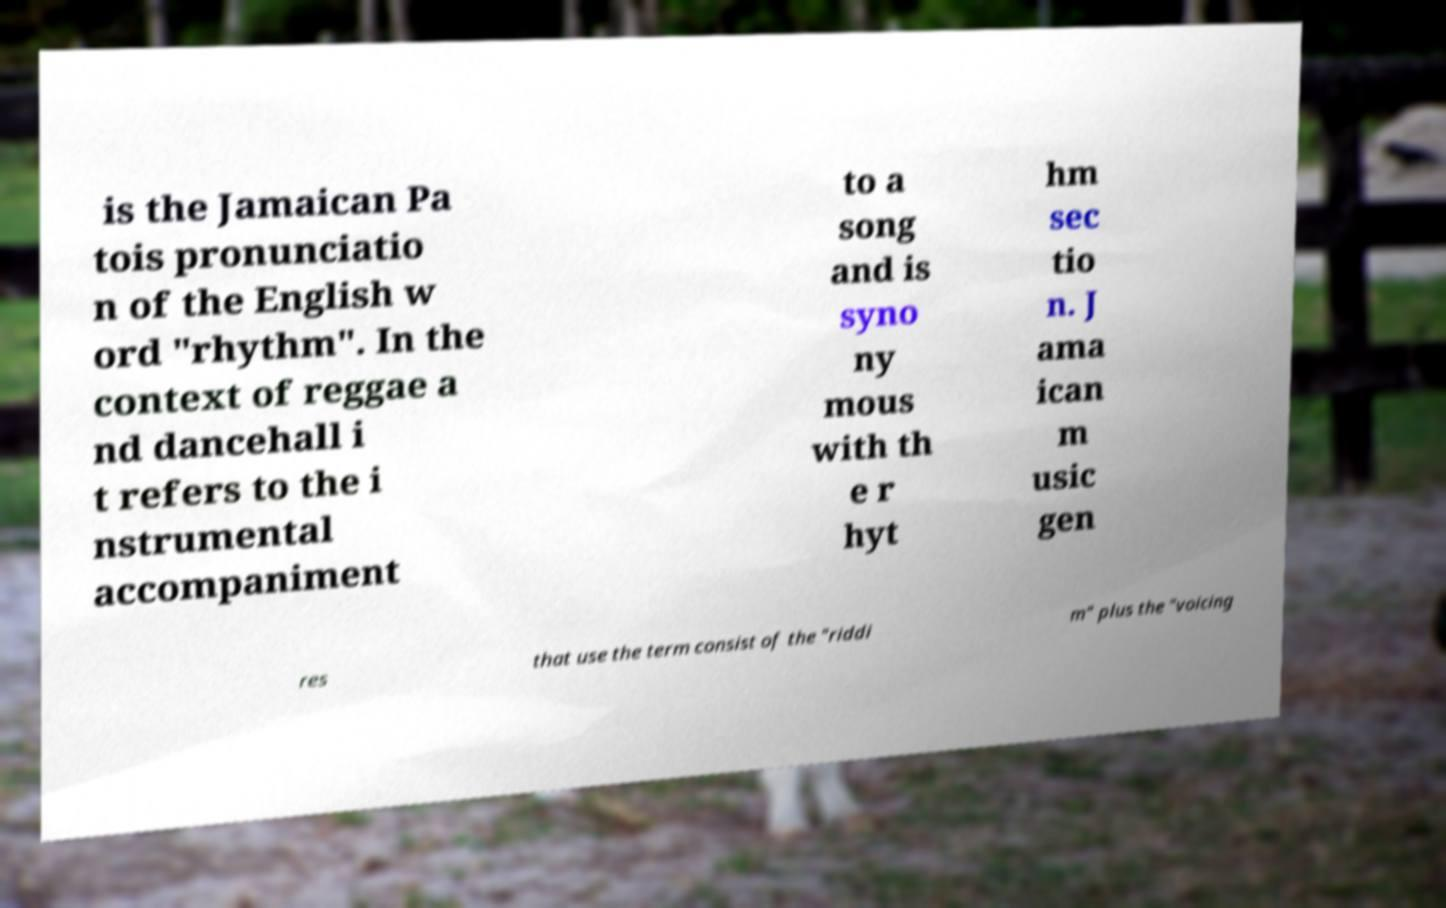Can you accurately transcribe the text from the provided image for me? is the Jamaican Pa tois pronunciatio n of the English w ord "rhythm". In the context of reggae a nd dancehall i t refers to the i nstrumental accompaniment to a song and is syno ny mous with th e r hyt hm sec tio n. J ama ican m usic gen res that use the term consist of the "riddi m" plus the "voicing 